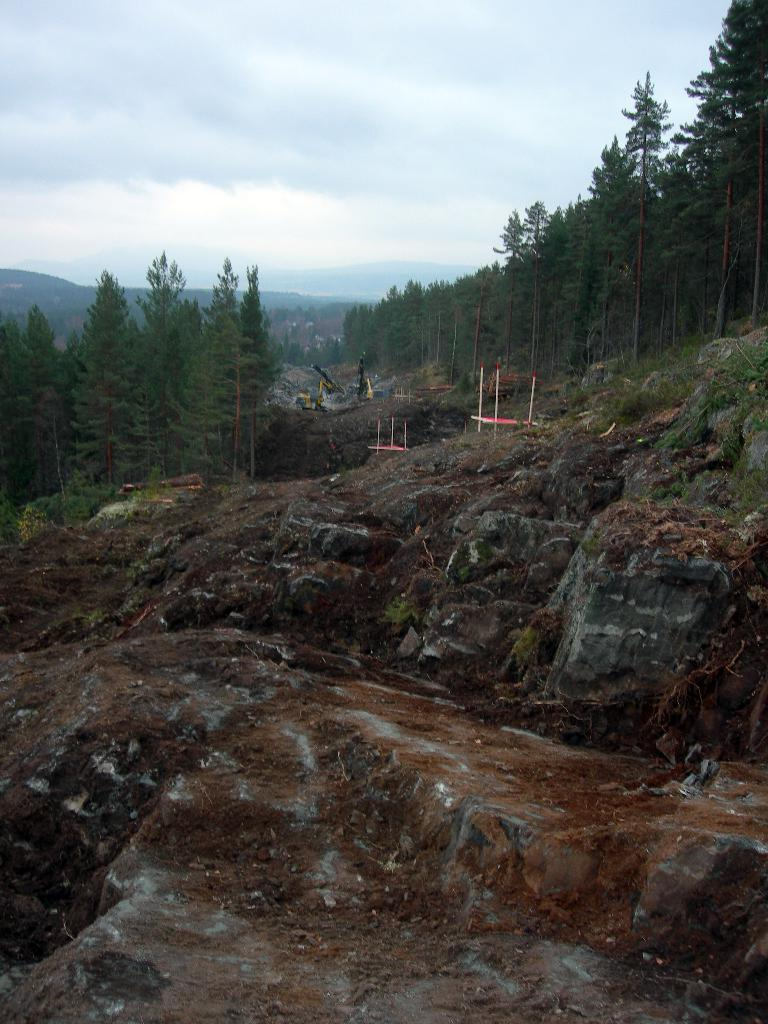What type of terrain is visible in the image? The ground is visible in the image, and there is grass present. What structures can be seen in the image? There are poles and cranes visible in the image. What type of vegetation is present in the image? Trees are visible in the image. What natural features can be seen in the image? Mountains are in the image. What is visible in the sky in the image? The sky is visible in the image, and clouds are present. What type of cracker is being used to aid digestion in the image? There is no cracker or reference to digestion present in the image. How many bags of popcorn are visible in the image? There are no bags of popcorn present in the image. 